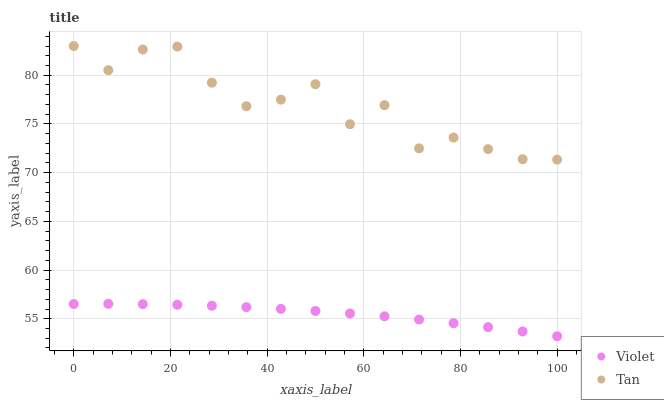Does Violet have the minimum area under the curve?
Answer yes or no. Yes. Does Tan have the maximum area under the curve?
Answer yes or no. Yes. Does Violet have the maximum area under the curve?
Answer yes or no. No. Is Violet the smoothest?
Answer yes or no. Yes. Is Tan the roughest?
Answer yes or no. Yes. Is Violet the roughest?
Answer yes or no. No. Does Violet have the lowest value?
Answer yes or no. Yes. Does Tan have the highest value?
Answer yes or no. Yes. Does Violet have the highest value?
Answer yes or no. No. Is Violet less than Tan?
Answer yes or no. Yes. Is Tan greater than Violet?
Answer yes or no. Yes. Does Violet intersect Tan?
Answer yes or no. No. 